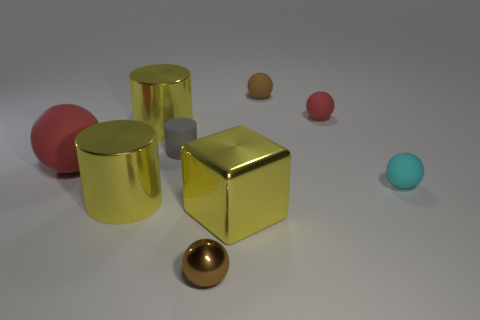Subtract all red spheres. How many spheres are left? 3 Subtract all yellow cylinders. How many cylinders are left? 1 Add 1 small gray rubber balls. How many objects exist? 10 Subtract all cylinders. How many objects are left? 6 Subtract all blue cylinders. How many red balls are left? 2 Subtract 2 spheres. How many spheres are left? 3 Subtract all brown cylinders. Subtract all blue spheres. How many cylinders are left? 3 Subtract all big yellow cubes. Subtract all small brown balls. How many objects are left? 6 Add 4 small objects. How many small objects are left? 9 Add 6 small cyan objects. How many small cyan objects exist? 7 